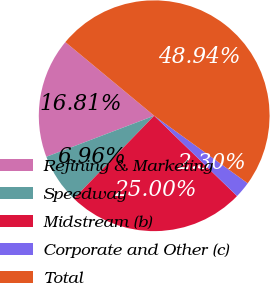Convert chart. <chart><loc_0><loc_0><loc_500><loc_500><pie_chart><fcel>Refining & Marketing<fcel>Speedway<fcel>Midstream (b)<fcel>Corporate and Other (c)<fcel>Total<nl><fcel>16.81%<fcel>6.96%<fcel>25.0%<fcel>2.3%<fcel>48.94%<nl></chart> 